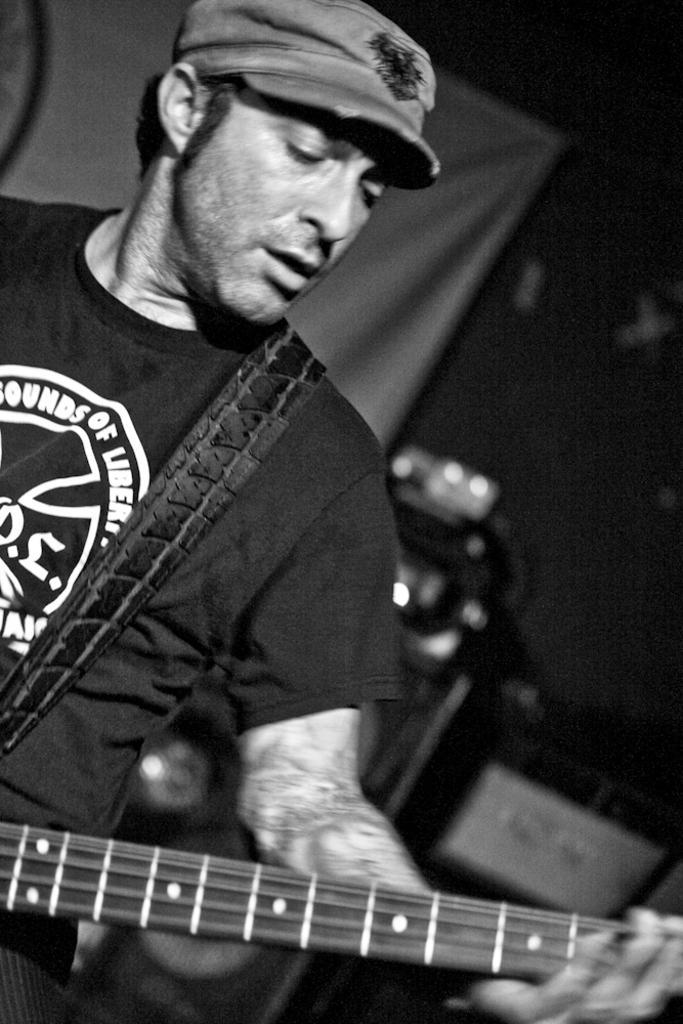Describe this image in one or two sentences. In this image i can see a person wearing a black t shirt and holding a guitar in his hands. 